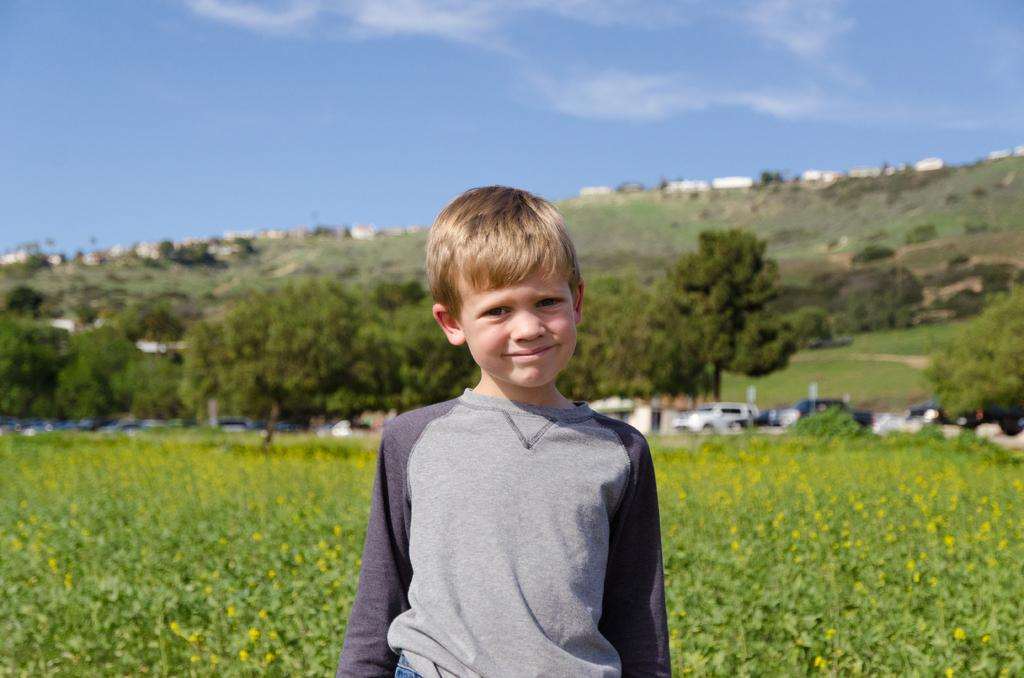What is located in the foreground of the image? There is a boy and small plants in the foreground of the image. What can be seen in the middle of the image? There are cars and trees in the middle of the image. What is visible at the top of the image? The sky is visible at the top of the image. What type of honey is being collected by the bears in the image? There are no bears or honey present in the image. How many sticks of butter can be seen on the table in the image? There is no table or butter present in the image. 